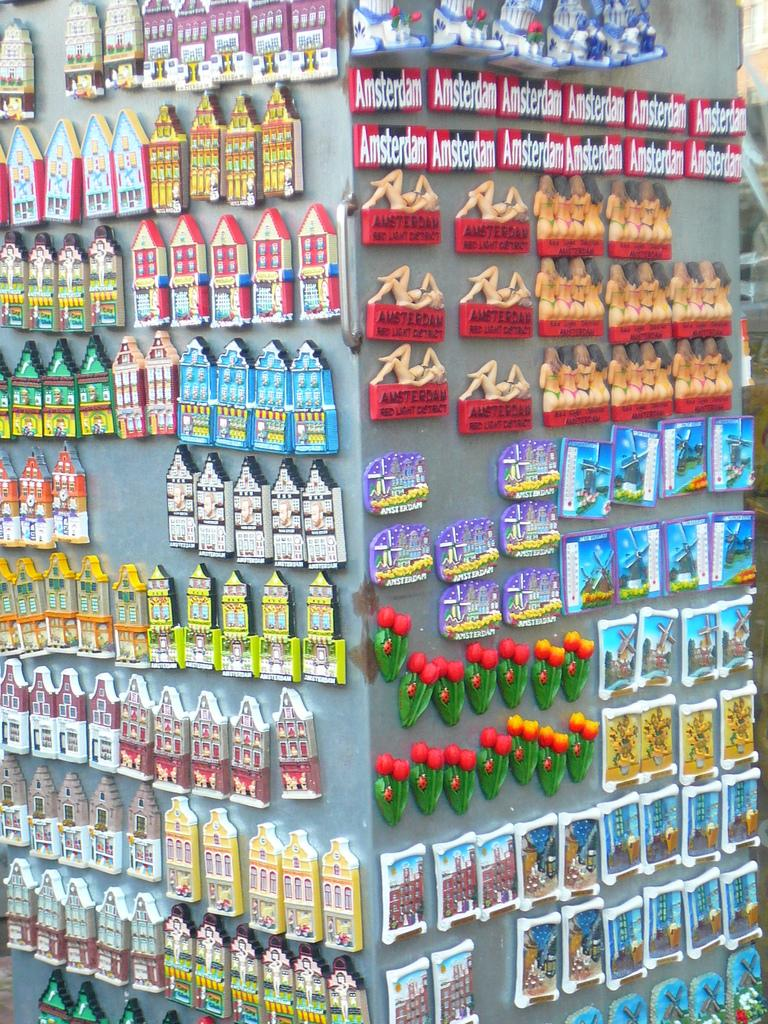<image>
Provide a brief description of the given image. Two rows of Amsterdam magnets are above rows of maked women magnets. 